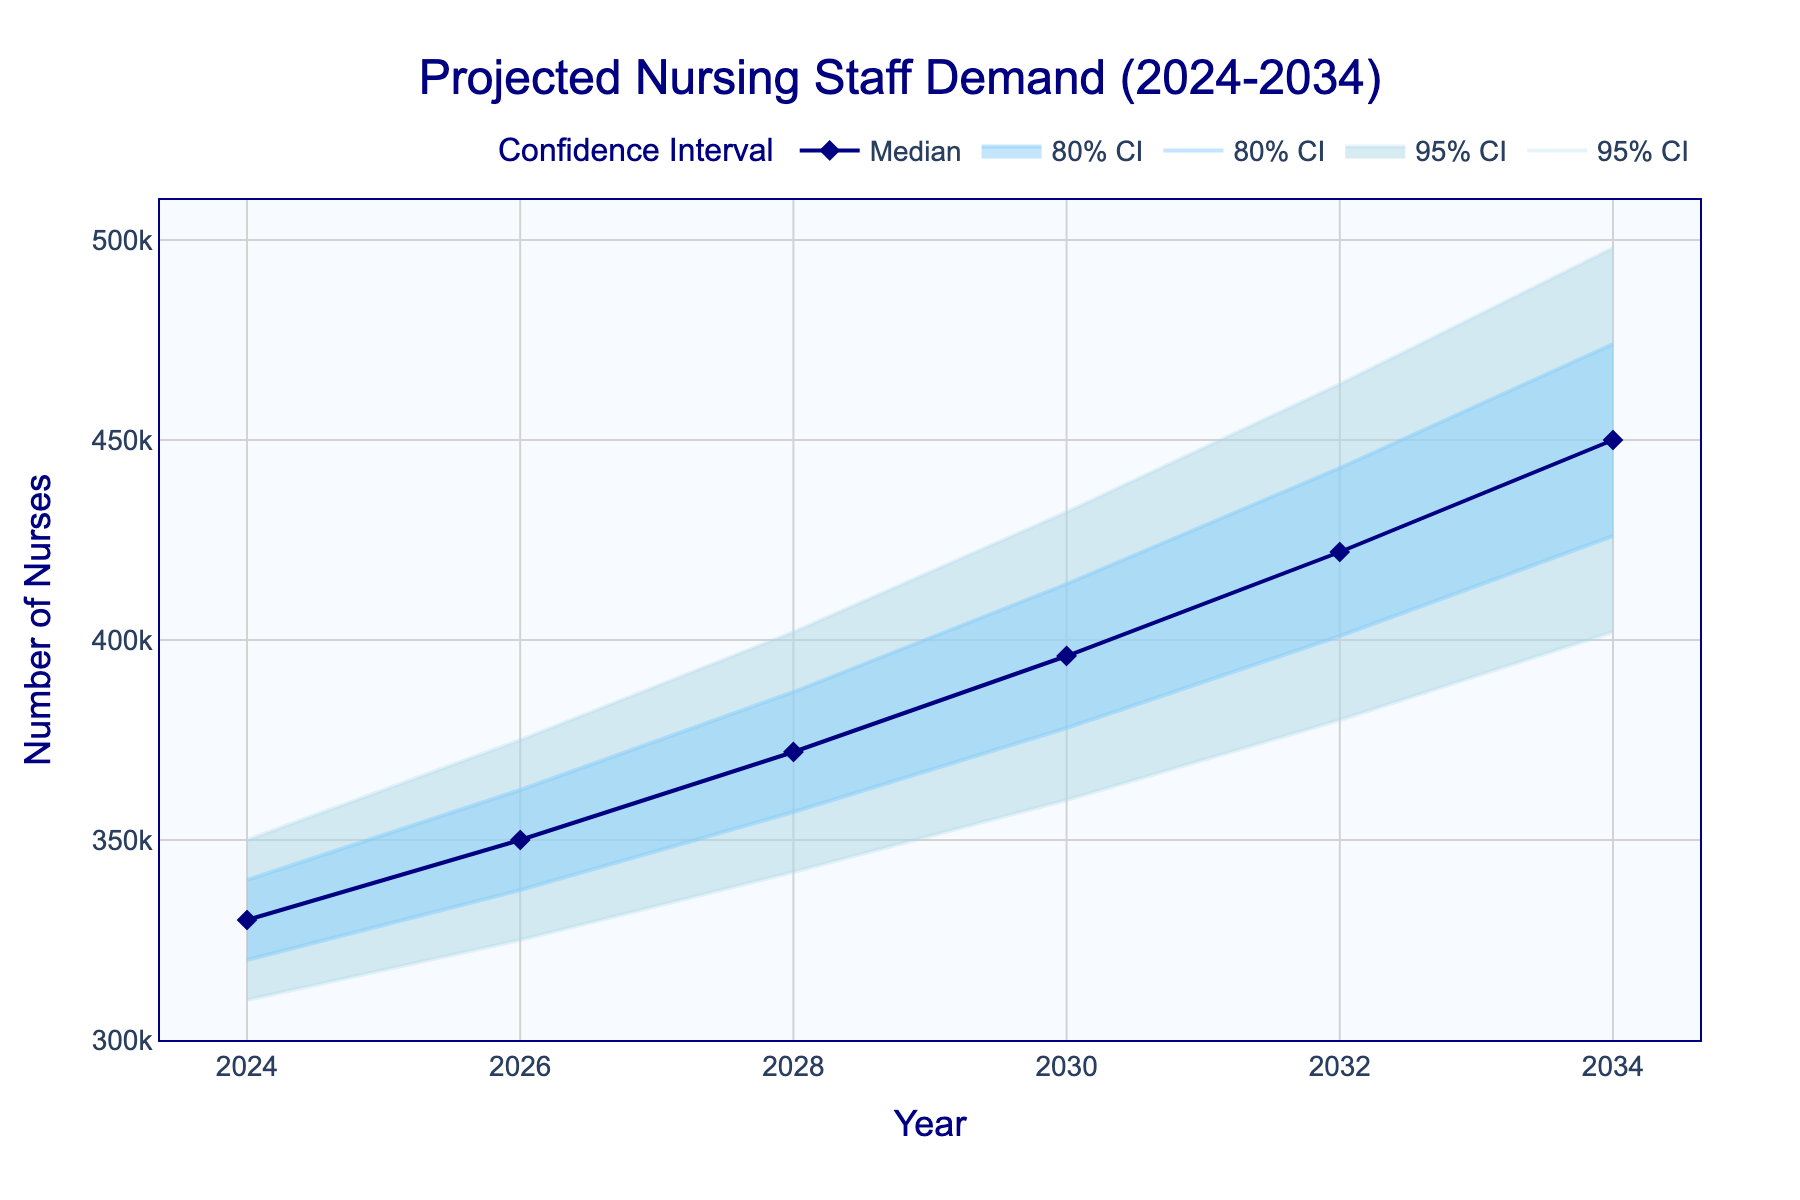What is the median projected nursing staff demand in 2030? Look at the 'Median' row for the year 2030 in the fan chart and identify the value.
Answer: 396000 What is the range of the 80% confidence interval in 2028? Find the 'High_80CI' and 'Low_80CI' values for the year 2028 and calculate the range by subtracting the low value from the high value: 387000 - 357000.
Answer: 30000 How much does the median projected nursing staff demand increase from 2024 to 2034? Subtract the 'Median' value in 2024 from the 'Median' value in 2034: 450000 - 330000.
Answer: 120000 Which year shows the highest upper bound in the 95% confidence interval? Examine the 'High_95CI' values for all years and find the maximum value and its corresponding year.
Answer: 2034 What is the difference between the lower bound of the 80% confidence interval in 2026 and the median projection for the same year? Look at the 'Low_80CI' and 'Median' values for 2026, then subtract 'Low_80CI' from 'Median': 350000 - 337500.
Answer: 12500 What trend do you observe in the median projected nursing staff demand over the next decade? Identify the median values from 2024 to 2034 and describe the overall trend in these values, noting whether they increase, decrease, or stay constant.
Answer: Increasing By how much does the lower bound of the 95% confidence interval in 2032 exceed that in 2024? Subtract the 'Low_95CI' value in 2024 from the 'Low_95CI' value in 2032: 380000 - 310000.
Answer: 70000 How do the widths of the 95% and 80% confidence intervals in 2030 compare? Calculate the range for both the 95% and 80% confidence intervals for 2030 and compare them. The 95% CI width is 432000 - 360000 = 72000, and the 80% CI width is 414000 - 378000 = 36000.
Answer: 95% CI is twice the width of 80% CI What is the median projection in the year with the largest increase in the lower bound of the 80% confidence interval compared to the previous year? Identify the year-to-year differences for the 'Low_80CI' values, find the maximum increase, and note the corresponding median value for that year. The largest increase is between 2028 and 2030 (378000 - 357000 = 21000). Median projection in 2030 is 396000.
Answer: 396000 What can you infer about the reliability of the median projection trend between 2024 and 2034 based on the confidence intervals? Assess the width and consistency of the 80% and 95% confidence intervals over the years. Narrow and consistent intervals indicate a more reliable projection.
Answer: Relatively reliable (both intervals widen but remain systematic) 